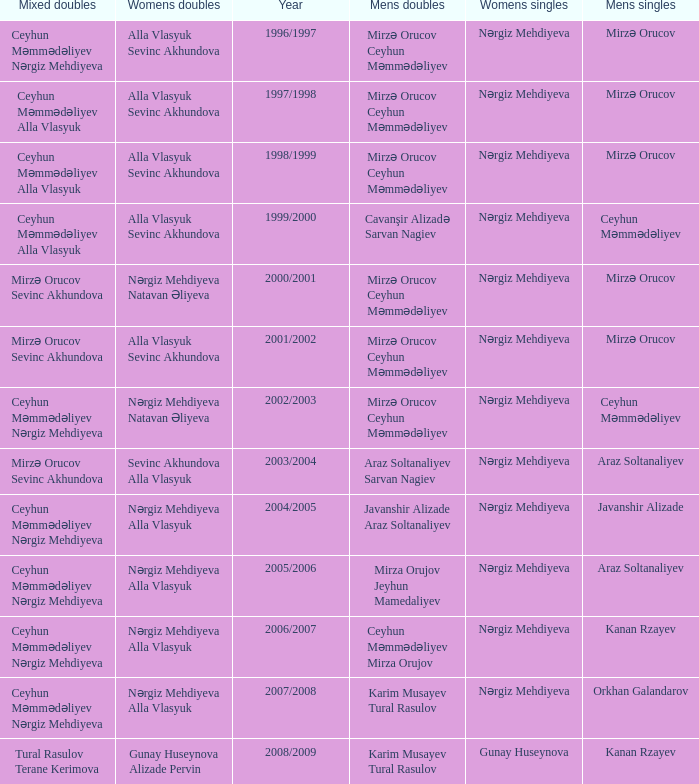Could you help me parse every detail presented in this table? {'header': ['Mixed doubles', 'Womens doubles', 'Year', 'Mens doubles', 'Womens singles', 'Mens singles'], 'rows': [['Ceyhun Məmmədəliyev Nərgiz Mehdiyeva', 'Alla Vlasyuk Sevinc Akhundova', '1996/1997', 'Mirzə Orucov Ceyhun Məmmədəliyev', 'Nərgiz Mehdiyeva', 'Mirzə Orucov'], ['Ceyhun Məmmədəliyev Alla Vlasyuk', 'Alla Vlasyuk Sevinc Akhundova', '1997/1998', 'Mirzə Orucov Ceyhun Məmmədəliyev', 'Nərgiz Mehdiyeva', 'Mirzə Orucov'], ['Ceyhun Məmmədəliyev Alla Vlasyuk', 'Alla Vlasyuk Sevinc Akhundova', '1998/1999', 'Mirzə Orucov Ceyhun Məmmədəliyev', 'Nərgiz Mehdiyeva', 'Mirzə Orucov'], ['Ceyhun Məmmədəliyev Alla Vlasyuk', 'Alla Vlasyuk Sevinc Akhundova', '1999/2000', 'Cavanşir Alizadə Sarvan Nagiev', 'Nərgiz Mehdiyeva', 'Ceyhun Məmmədəliyev'], ['Mirzə Orucov Sevinc Akhundova', 'Nərgiz Mehdiyeva Natavan Əliyeva', '2000/2001', 'Mirzə Orucov Ceyhun Məmmədəliyev', 'Nərgiz Mehdiyeva', 'Mirzə Orucov'], ['Mirzə Orucov Sevinc Akhundova', 'Alla Vlasyuk Sevinc Akhundova', '2001/2002', 'Mirzə Orucov Ceyhun Məmmədəliyev', 'Nərgiz Mehdiyeva', 'Mirzə Orucov'], ['Ceyhun Məmmədəliyev Nərgiz Mehdiyeva', 'Nərgiz Mehdiyeva Natavan Əliyeva', '2002/2003', 'Mirzə Orucov Ceyhun Məmmədəliyev', 'Nərgiz Mehdiyeva', 'Ceyhun Məmmədəliyev'], ['Mirzə Orucov Sevinc Akhundova', 'Sevinc Akhundova Alla Vlasyuk', '2003/2004', 'Araz Soltanaliyev Sarvan Nagiev', 'Nərgiz Mehdiyeva', 'Araz Soltanaliyev'], ['Ceyhun Məmmədəliyev Nərgiz Mehdiyeva', 'Nərgiz Mehdiyeva Alla Vlasyuk', '2004/2005', 'Javanshir Alizade Araz Soltanaliyev', 'Nərgiz Mehdiyeva', 'Javanshir Alizade'], ['Ceyhun Məmmədəliyev Nərgiz Mehdiyeva', 'Nərgiz Mehdiyeva Alla Vlasyuk', '2005/2006', 'Mirza Orujov Jeyhun Mamedaliyev', 'Nərgiz Mehdiyeva', 'Araz Soltanaliyev'], ['Ceyhun Məmmədəliyev Nərgiz Mehdiyeva', 'Nərgiz Mehdiyeva Alla Vlasyuk', '2006/2007', 'Ceyhun Məmmədəliyev Mirza Orujov', 'Nərgiz Mehdiyeva', 'Kanan Rzayev'], ['Ceyhun Məmmədəliyev Nərgiz Mehdiyeva', 'Nərgiz Mehdiyeva Alla Vlasyuk', '2007/2008', 'Karim Musayev Tural Rasulov', 'Nərgiz Mehdiyeva', 'Orkhan Galandarov'], ['Tural Rasulov Terane Kerimova', 'Gunay Huseynova Alizade Pervin', '2008/2009', 'Karim Musayev Tural Rasulov', 'Gunay Huseynova', 'Kanan Rzayev']]} Who are all the womens doubles for the year 2008/2009? Gunay Huseynova Alizade Pervin. 